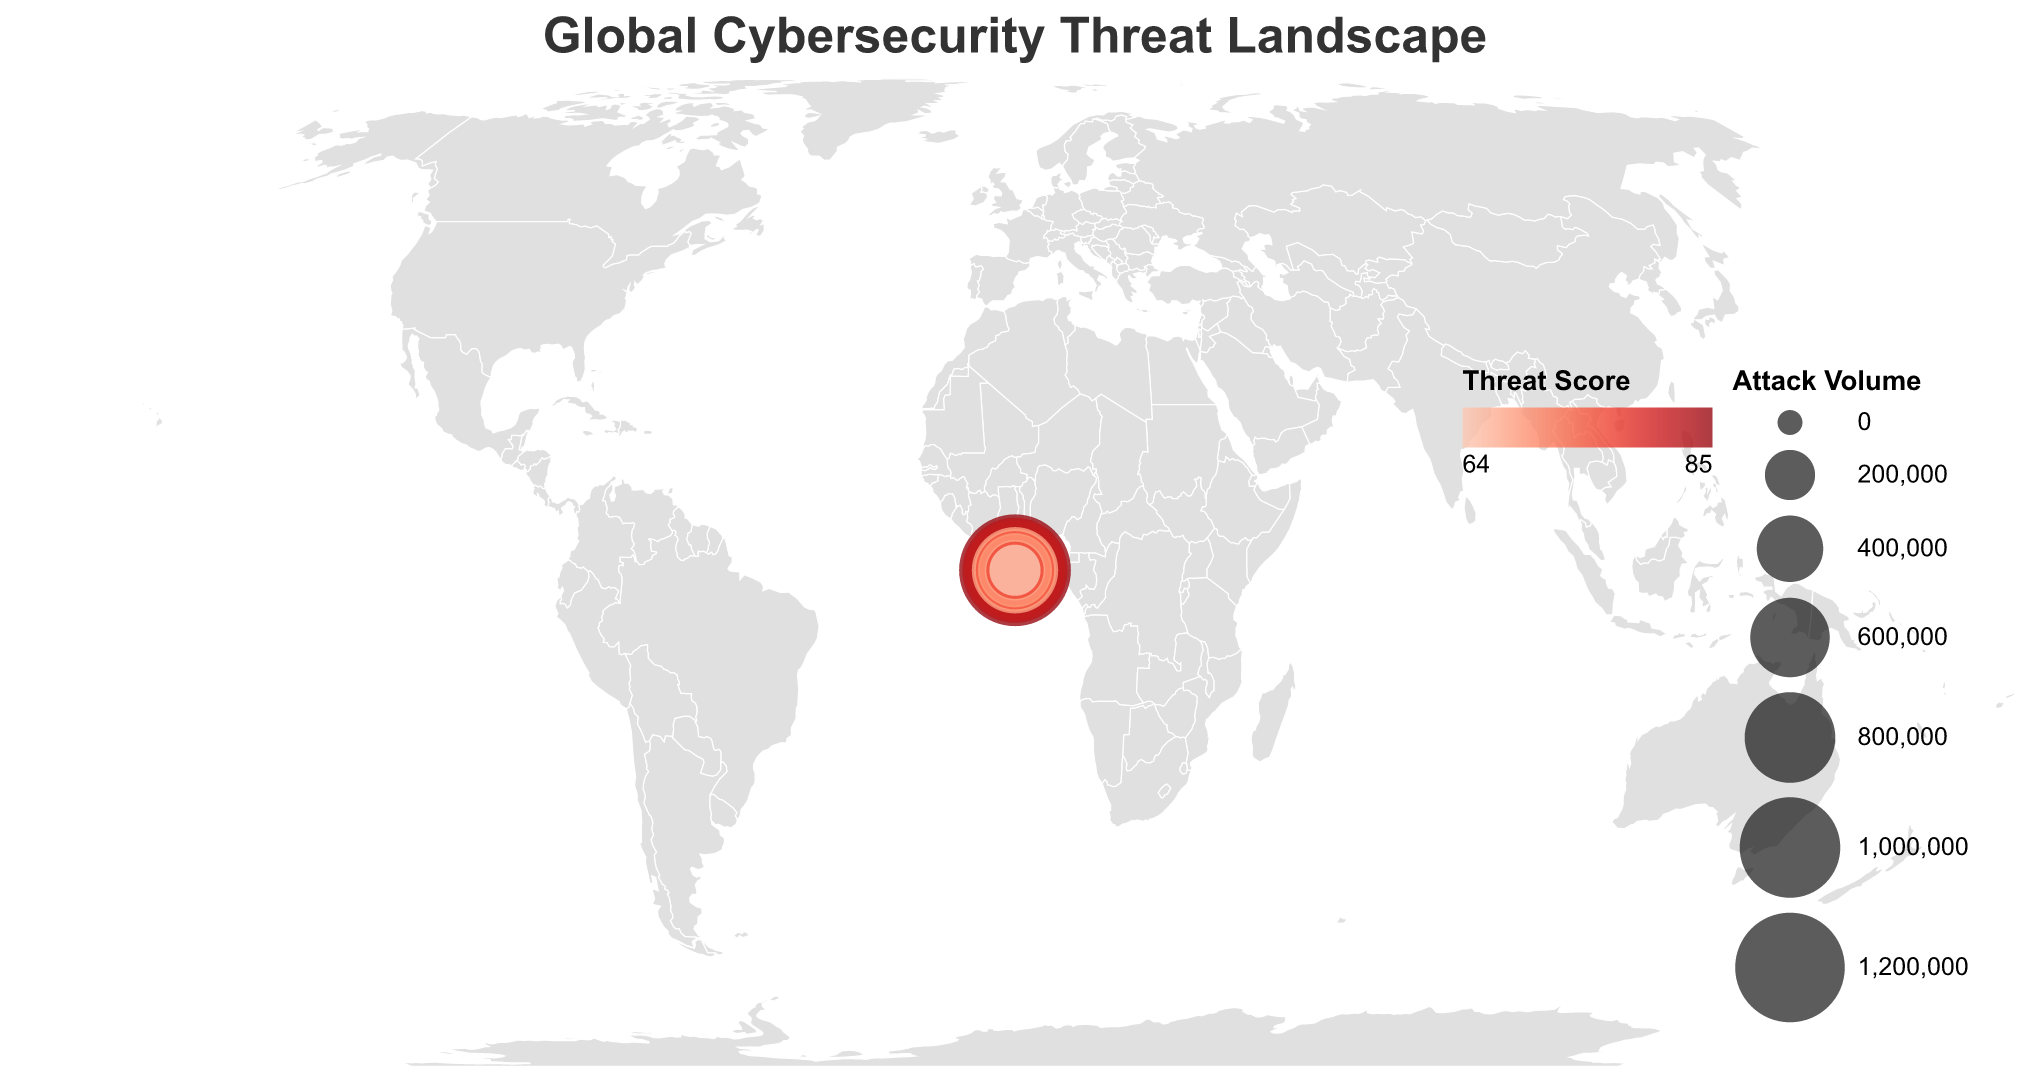What's the title of the figure? The title is positioned at the top of the figure, indicating the main subject being depicted. Here, the title is displayed in the JSON snippet under the title property.
Answer: "Global Cybersecurity Threat Landscape" Which country has the highest Threat Score? The color scale represents the Threat Score, with darker shades indicating higher values. By inspecting the figure, the darkest circle corresponds to the United States.
Answer: United States What is the Major Threat Type in Japan? By examining the tooltip information for Japan, we can see the specific threat type mentioned. Looking at the relevant attributes in the data, we find this.
Answer: IoT Vulnerabilities How many countries have a Threat Score greater than 75? We count the countries with Threat Scores over 75 by referring to the data points and observing the figure colors where Threat Scores exceed this threshold. This includes United States, Russia, United Kingdom, and Israel.
Answer: 4 Which country has the lowest Attack Volume and what's the corresponding threat type? By observing the size of the circles, the smallest circle represents the lowest Attack Volume. Referring to the tooltip for the smallest circle provides the answer.
Answer: Singapore, Social Engineering Compare the Attack Volume between China and Russia. Which one is higher? Comparing the sizes of the circles representing China and Russia, Russia's circle is larger, hence indicating a higher Attack Volume.
Answer: Russia What is the combined Attack Volume of Germany and Brazil? From the data, sum up the Attack Volumes: 520,000 (Germany) + 650,000 (Brazil) = 1,170,000
Answer: 1,170,000 Rank the top three countries based on their Threat Score. By ordering the Threat Scores from the highest values: United States (85), Russia (82), Israel (76).
Answer: United States, Russia, Israel Which country experiences Ransomware as the major threat? Referring to the Major Threat Type attribute for each country, the tooltip for the corresponding country will display this information.
Answer: United States 